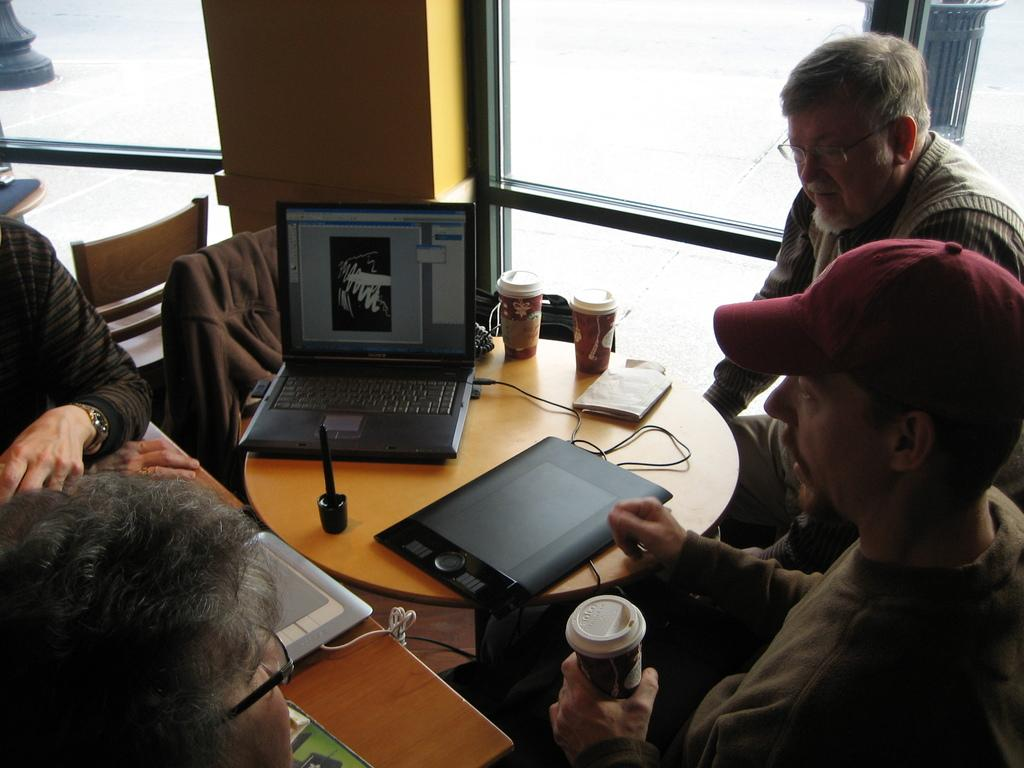What are the people in the image doing? The people in the image are sitting in front of tables. What can be seen on the tables? Laptops, glasses, and other objects are present on the tables. What type of wall can be seen in the image? There is a framed glass wall in the image. What furniture is visible in the image? Chairs are visible in the image. How many kittens are playing with the laptop cords in the image? There are no kittens present in the image, and therefore no such activity can be observed. 